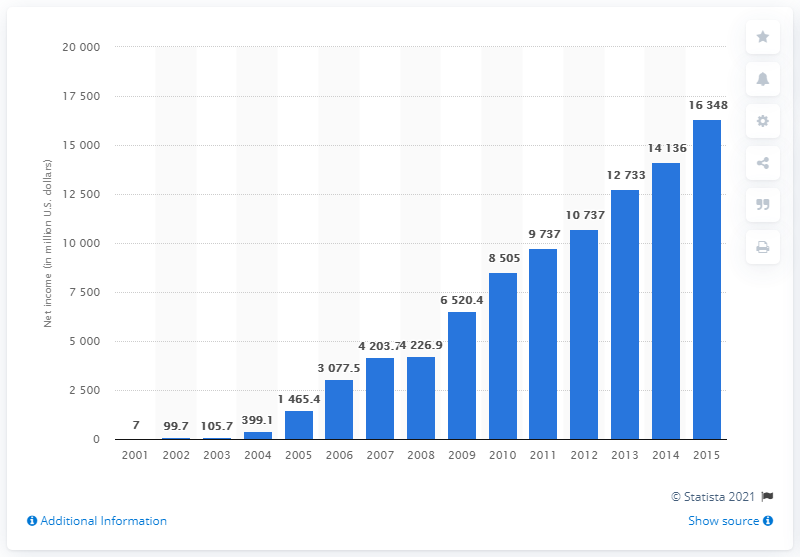Draw attention to some important aspects in this diagram. Google's net income increased from 2001 to 2015, with a total of 16,348. 